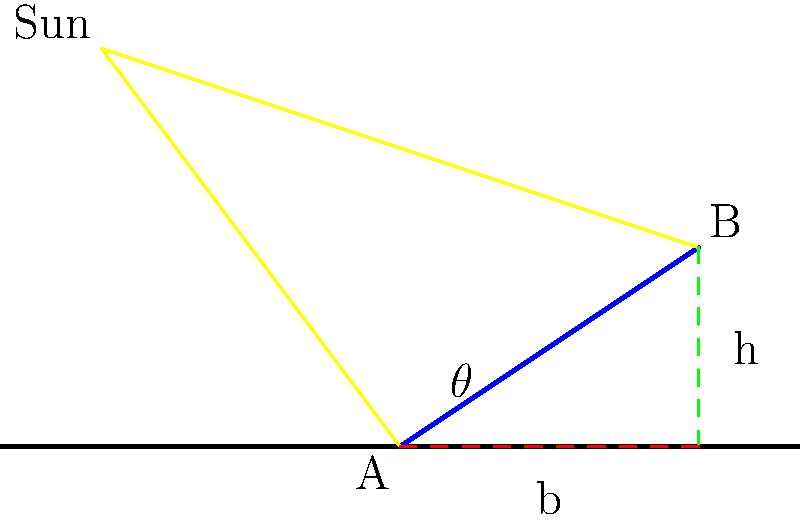As a sustainable artist designing a solar-powered art studio, you need to determine the optimal angle for installing solar panels. Given that the sun's rays are perpendicular to the panel surface when it's most efficient, and the sun's altitude angle is 30° at solar noon, what is the optimal tilt angle $\theta$ for the solar panel with respect to the horizontal ground? To find the optimal tilt angle for the solar panel, we need to consider that the panel should be perpendicular to the sun's rays for maximum efficiency. Let's approach this step-by-step:

1. The sun's altitude angle is given as 30° at solar noon. This is the angle between the sun's rays and the horizontal ground.

2. For the solar panel to be perpendicular to the sun's rays, it must form a right angle (90°) with them.

3. We can use the concept of complementary angles. Two angles are complementary if they add up to 90°.

4. Let $\theta$ be the tilt angle of the solar panel with respect to the horizontal ground.

5. For the panel to be perpendicular to the sun's rays:
   $\theta + 30° = 90°$

6. Solving for $\theta$:
   $\theta = 90° - 30° = 60°$

7. Therefore, the optimal tilt angle for the solar panel is 60° from the horizontal.

This setup ensures that at solar noon, when the sun is at its highest point in the sky, the solar panel will be perfectly perpendicular to the sun's rays, maximizing energy capture for your sustainable art studio.
Answer: 60° 